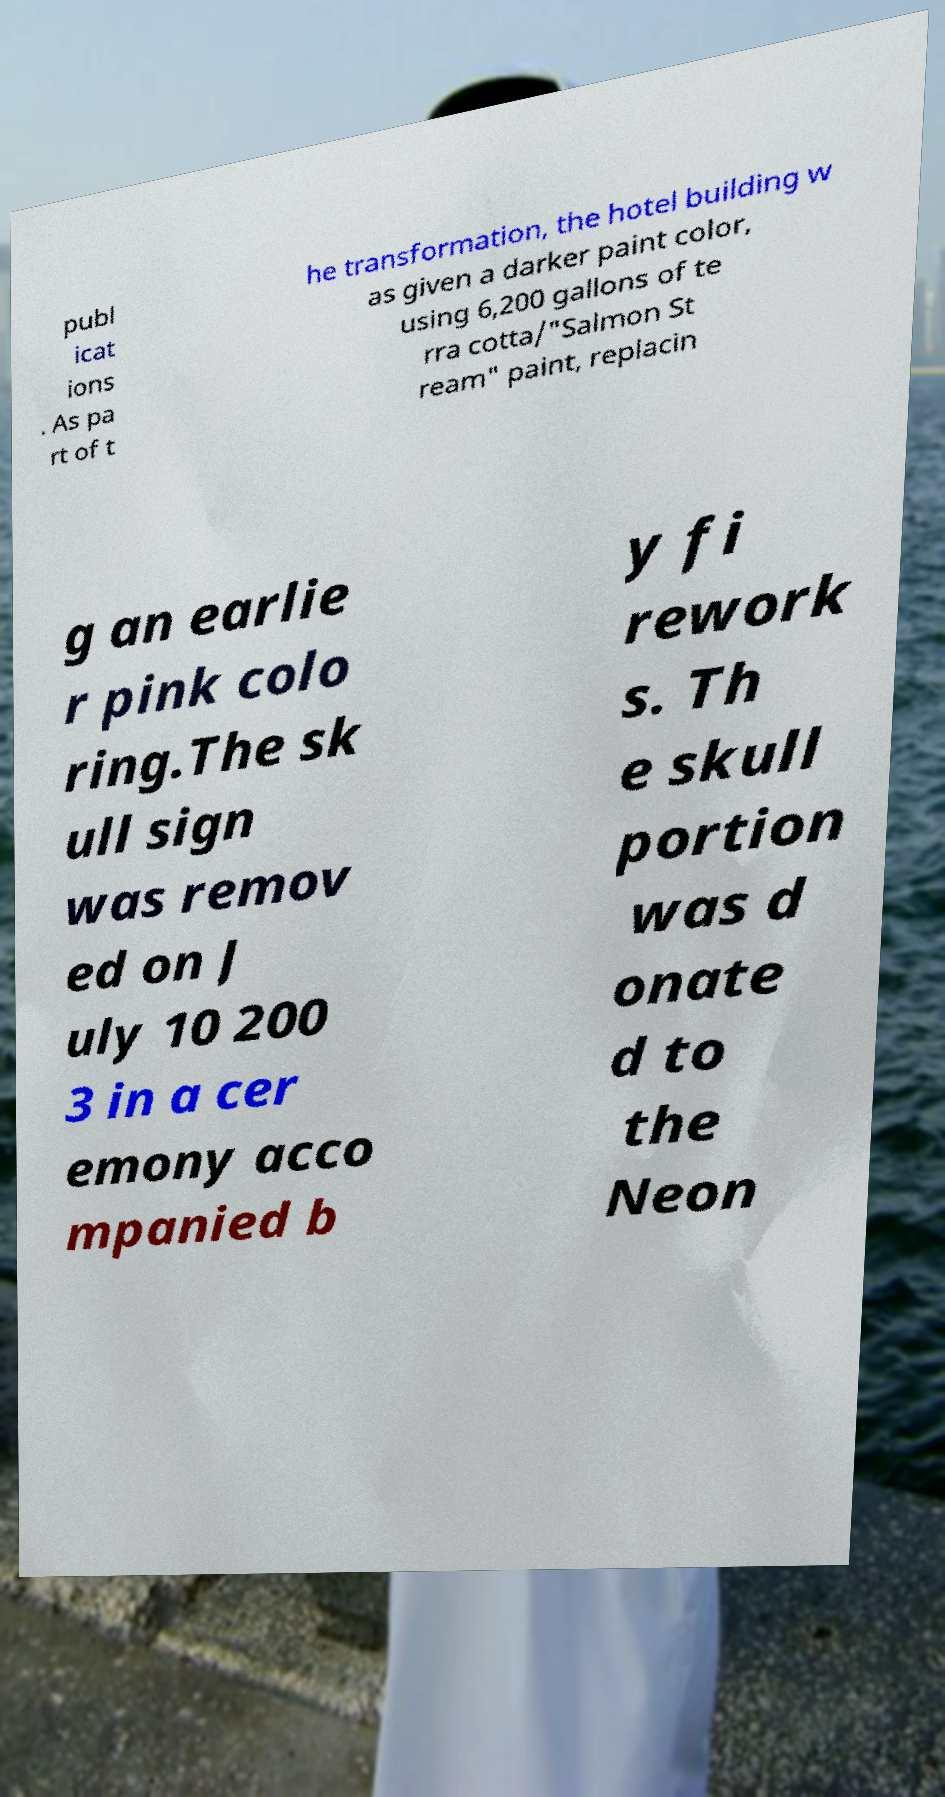For documentation purposes, I need the text within this image transcribed. Could you provide that? publ icat ions . As pa rt of t he transformation, the hotel building w as given a darker paint color, using 6,200 gallons of te rra cotta/"Salmon St ream" paint, replacin g an earlie r pink colo ring.The sk ull sign was remov ed on J uly 10 200 3 in a cer emony acco mpanied b y fi rework s. Th e skull portion was d onate d to the Neon 